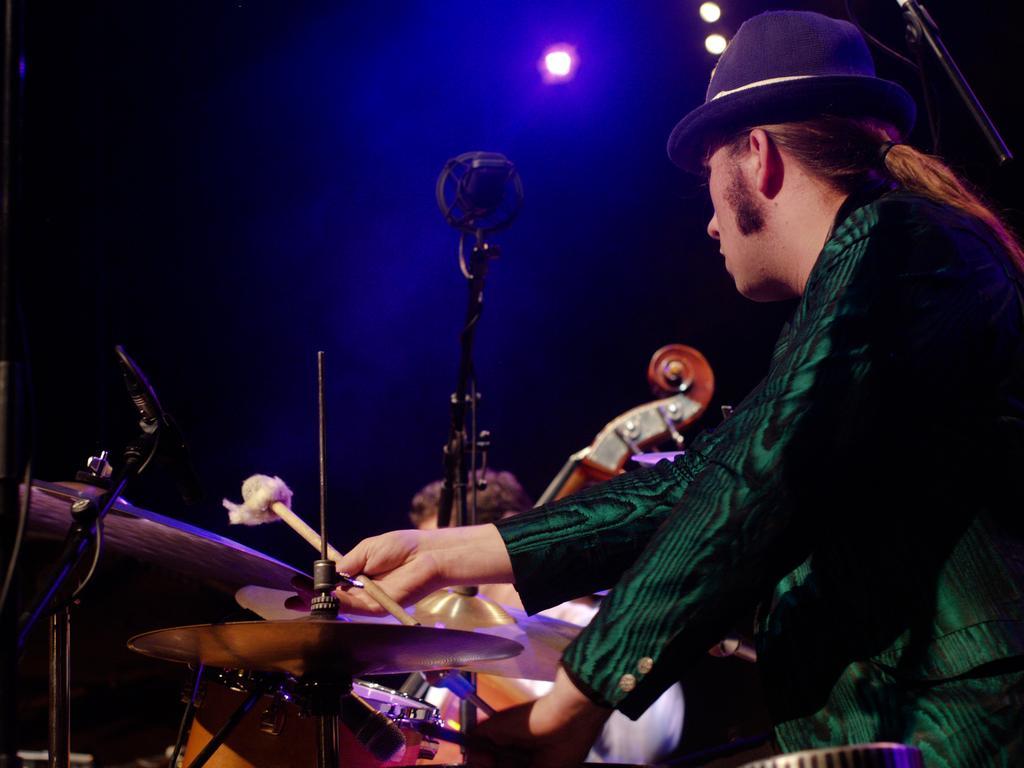How would you summarize this image in a sentence or two? This picture shows a man seated and playing drums and we see a microphone 